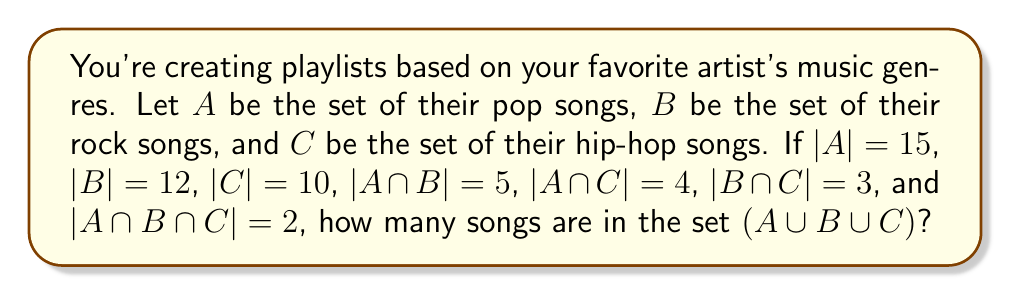Help me with this question. To solve this problem, we'll use the Inclusion-Exclusion Principle for three sets:

$$|A ∪ B ∪ C| = |A| + |B| + |C| - |A ∩ B| - |A ∩ C| - |B ∩ C| + |A ∩ B ∩ C|$$

Let's substitute the given values:

1. |A| = 15
2. |B| = 12
3. |C| = 10
4. |A ∩ B| = 5
5. |A ∩ C| = 4
6. |B ∩ C| = 3
7. |A ∩ B ∩ C| = 2

Now, let's calculate:

$$|A ∪ B ∪ C| = 15 + 12 + 10 - 5 - 4 - 3 + 2$$

$$|A ∪ B ∪ C| = 37 - 12 + 2$$

$$|A ∪ B ∪ C| = 27$$

Therefore, the total number of unique songs in the combined playlist is 27.
Answer: 27 songs 